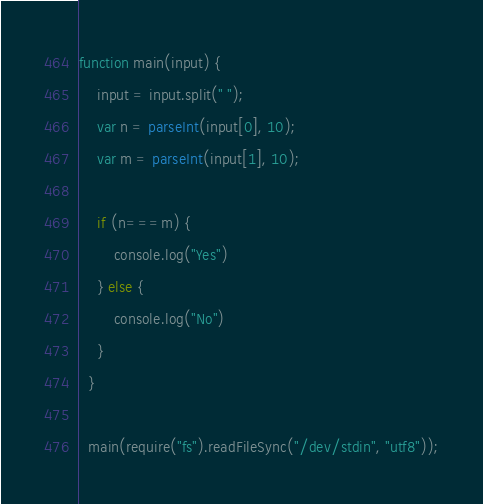Convert code to text. <code><loc_0><loc_0><loc_500><loc_500><_JavaScript_>function main(input) {
    input = input.split(" ");
    var n = parseInt(input[0], 10);
    var m = parseInt(input[1], 10);

    if (n===m) {
        console.log("Yes")
    } else {
        console.log("No")
    }
  }
   
  main(require("fs").readFileSync("/dev/stdin", "utf8"));

</code> 